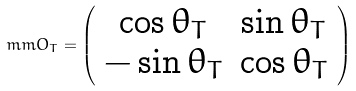<formula> <loc_0><loc_0><loc_500><loc_500>\ m m { O } _ { T } = \left ( \begin{array} { c c } \cos \theta _ { T } & \sin \theta _ { T } \\ - \sin \theta _ { T } & \cos \theta _ { T } \end{array} \right )</formula> 